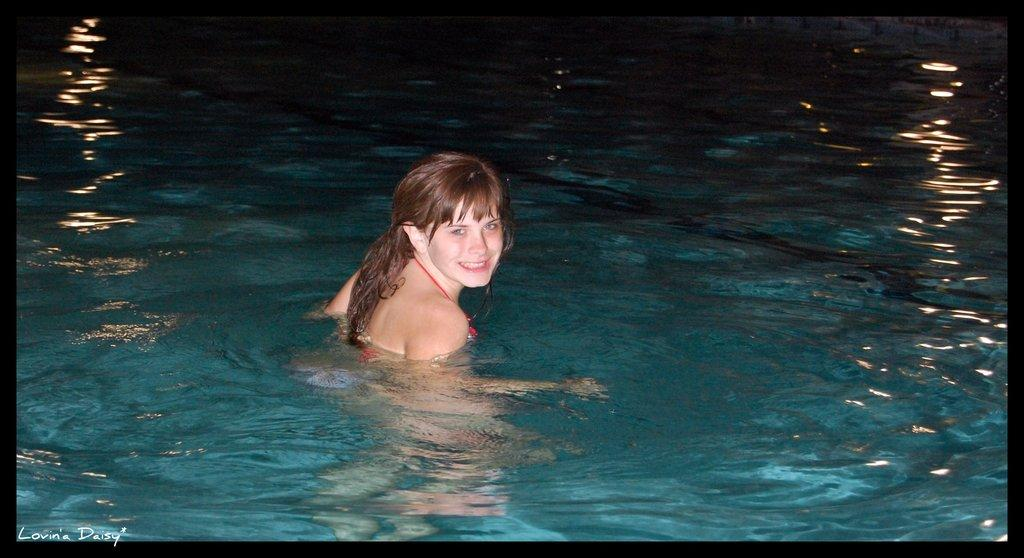Who is the main subject in the image? There is a woman in the image. What is the woman doing in the image? The woman is swimming in the water. How many girls are present in the image? There is no mention of girls in the image; it only features a woman. What type of honey can be seen dripping from the woman's hair in the image? There is no honey present in the image; the woman is swimming in the water. 